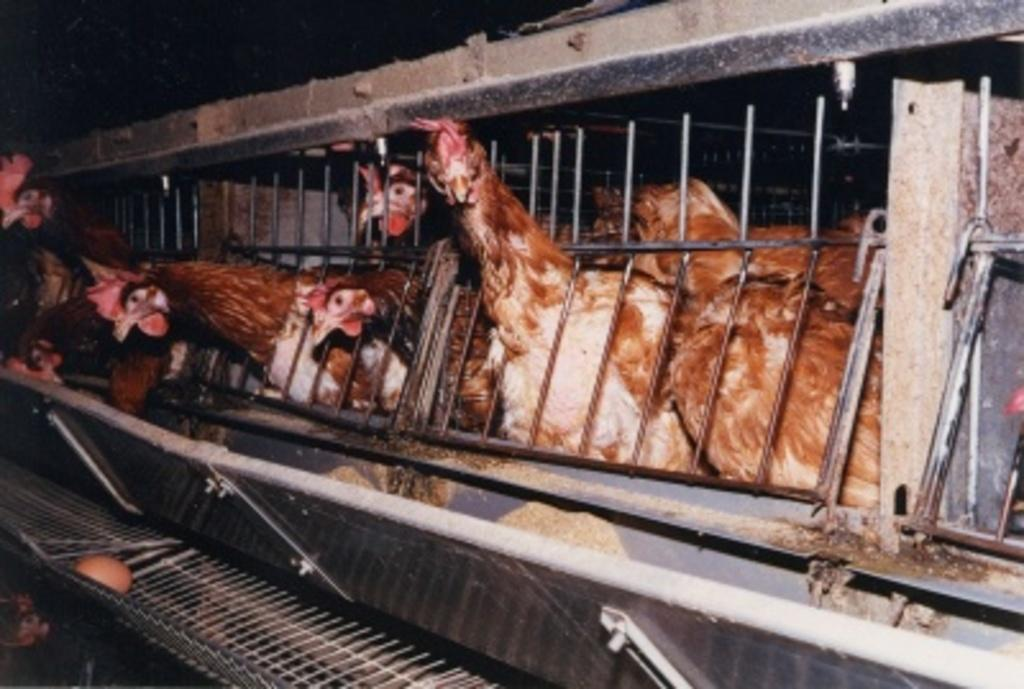What animals are present in the image? There are cocks in the image. Where are the cocks located? The cocks are in a cage. What color are the cocks? The cocks are brown in color. What can be observed about the background of the image? The background of the image is dark. How does the image respond to an earthquake? There is no indication of an earthquake or any response to one in the image, as it features cocks in a cage. 